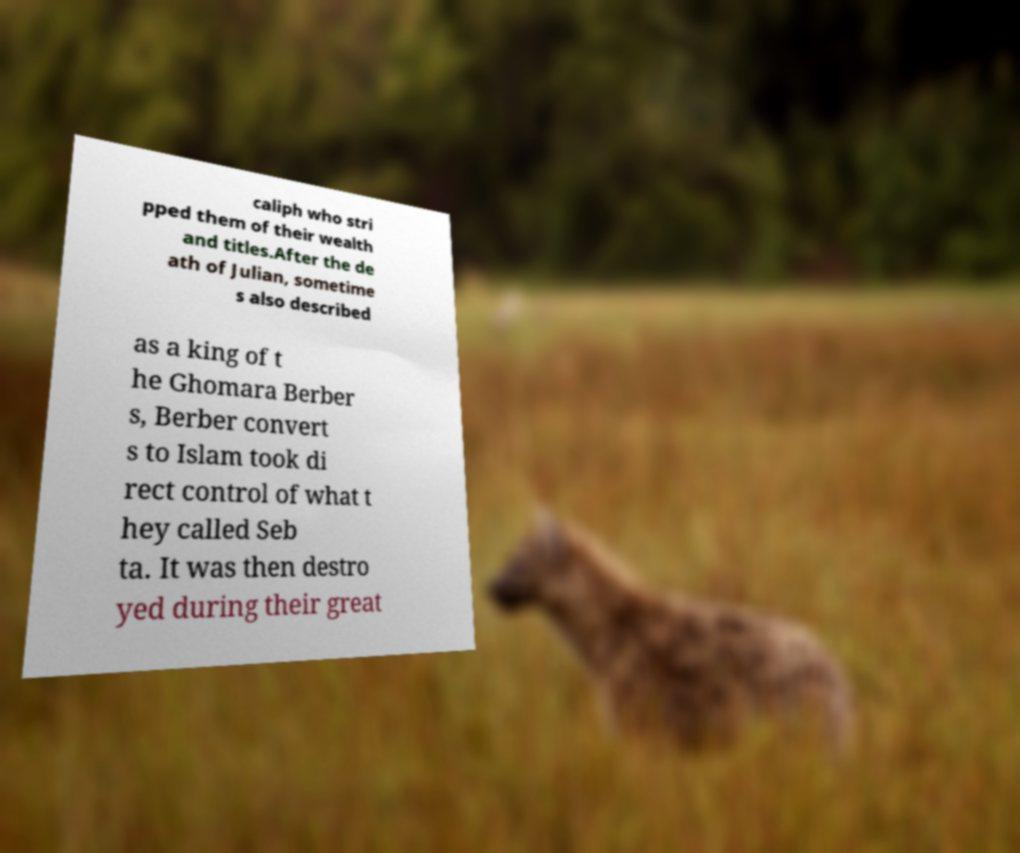What messages or text are displayed in this image? I need them in a readable, typed format. caliph who stri pped them of their wealth and titles.After the de ath of Julian, sometime s also described as a king of t he Ghomara Berber s, Berber convert s to Islam took di rect control of what t hey called Seb ta. It was then destro yed during their great 